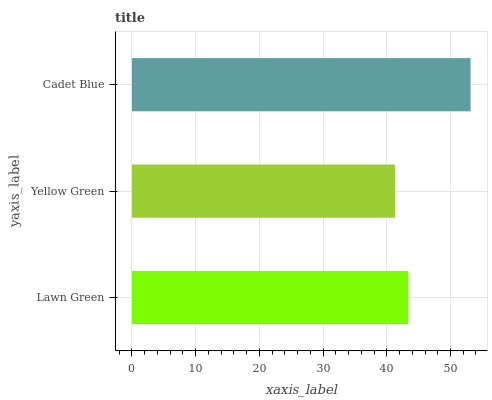Is Yellow Green the minimum?
Answer yes or no. Yes. Is Cadet Blue the maximum?
Answer yes or no. Yes. Is Cadet Blue the minimum?
Answer yes or no. No. Is Yellow Green the maximum?
Answer yes or no. No. Is Cadet Blue greater than Yellow Green?
Answer yes or no. Yes. Is Yellow Green less than Cadet Blue?
Answer yes or no. Yes. Is Yellow Green greater than Cadet Blue?
Answer yes or no. No. Is Cadet Blue less than Yellow Green?
Answer yes or no. No. Is Lawn Green the high median?
Answer yes or no. Yes. Is Lawn Green the low median?
Answer yes or no. Yes. Is Yellow Green the high median?
Answer yes or no. No. Is Cadet Blue the low median?
Answer yes or no. No. 